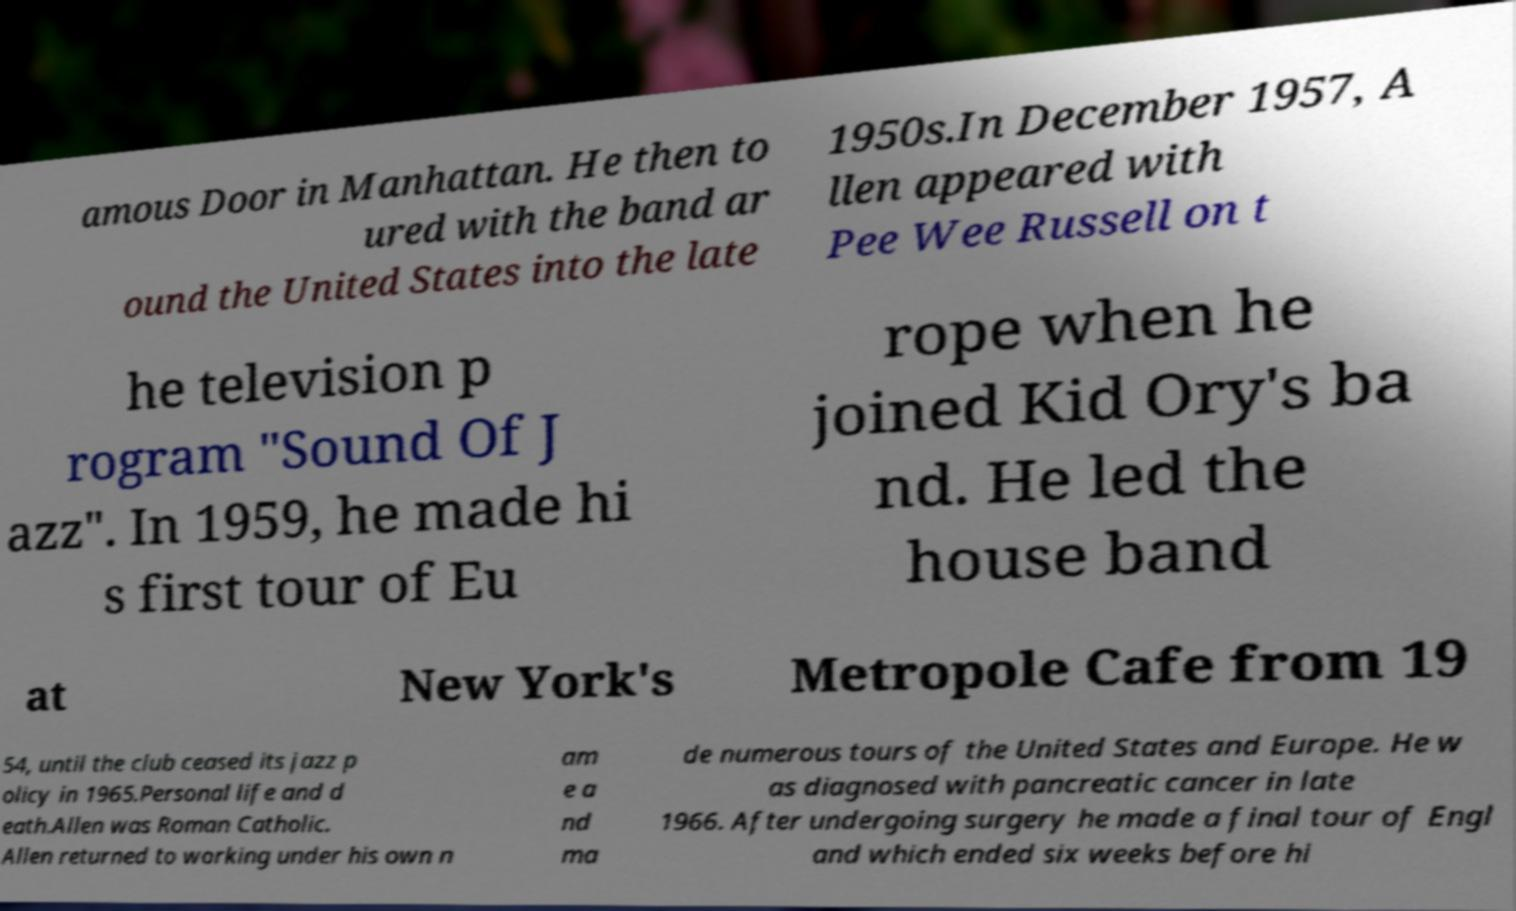Please read and relay the text visible in this image. What does it say? amous Door in Manhattan. He then to ured with the band ar ound the United States into the late 1950s.In December 1957, A llen appeared with Pee Wee Russell on t he television p rogram "Sound Of J azz". In 1959, he made hi s first tour of Eu rope when he joined Kid Ory's ba nd. He led the house band at New York's Metropole Cafe from 19 54, until the club ceased its jazz p olicy in 1965.Personal life and d eath.Allen was Roman Catholic. Allen returned to working under his own n am e a nd ma de numerous tours of the United States and Europe. He w as diagnosed with pancreatic cancer in late 1966. After undergoing surgery he made a final tour of Engl and which ended six weeks before hi 